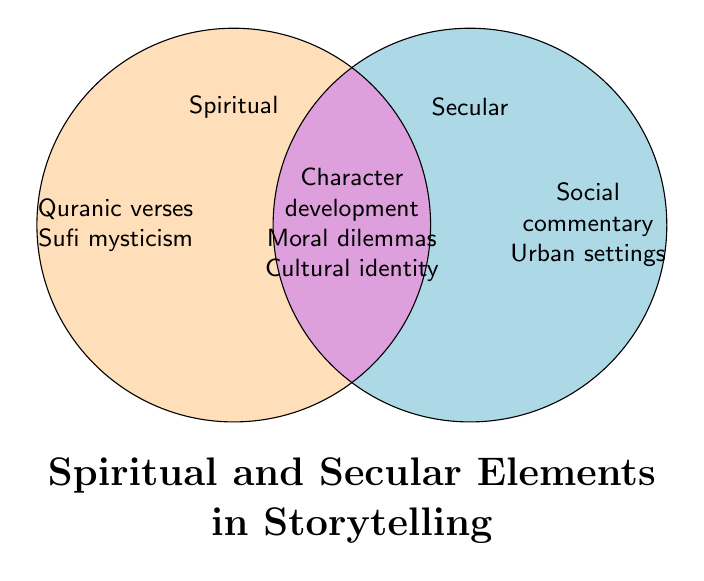What are some elements that are unique to Spiritual storytelling? The unique elements in Spiritual storytelling are on the left side (Spiritual section) of the Venn diagram.
Answer: Quranic verses, Sufi mysticism, Divine revelation, Prophetic narratives, Religious symbolism What are some elements that are unique to Secular storytelling? The unique elements in Secular storytelling are on the right side (Secular section) of the Venn diagram.
Answer: Social commentary, Political critique, Urban settings, Modern technology, Secular humanism, Economic themes, Scientific concepts Which storytelling elements are common to both Spiritual and Secular? The common elements are found in the overlapping section (Both) in the center of the Venn diagram.
Answer: Character development, Moral dilemmas, Historical allegories, Cultural identity, Existential questions, Psychological depth, Ethical conflicts How many storytelling elements are listed in the Spiritual section? Count all the elements in the Spiritual section only.
Answer: 5 elements Which side has more unique elements, Spiritual or Secular? Compare the count of unique elements in both the Spiritual and Secular sections.
Answer: Secular Are ethical conflicts considered a Secular element? Check if 'Ethical conflicts' is listed exclusively in the Secular section or overlap section.
Answer: No How do Urban settings relate to Religious symbolism according to the Venn diagram? Assess the sections of the Venn diagram to determine where Urban settings and Religious symbolism are placed.
Answer: They belong to different sections; Urban settings are Secular while Religious symbolism is Spiritual Which section includes Moral dilemmas? Identify the part of the Venn diagram where Moral dilemmas are categorized.
Answer: Both Do Scientific concepts overlap with Sufi mysticism in storytelling? Examine the placement of Scientific concepts and Sufi mysticism in the Venn diagram.
Answer: No What does the overlapping section indicate in this Venn diagram? It represents elements that are common to both Spiritual and Secular storytelling.
Answer: Common elements 